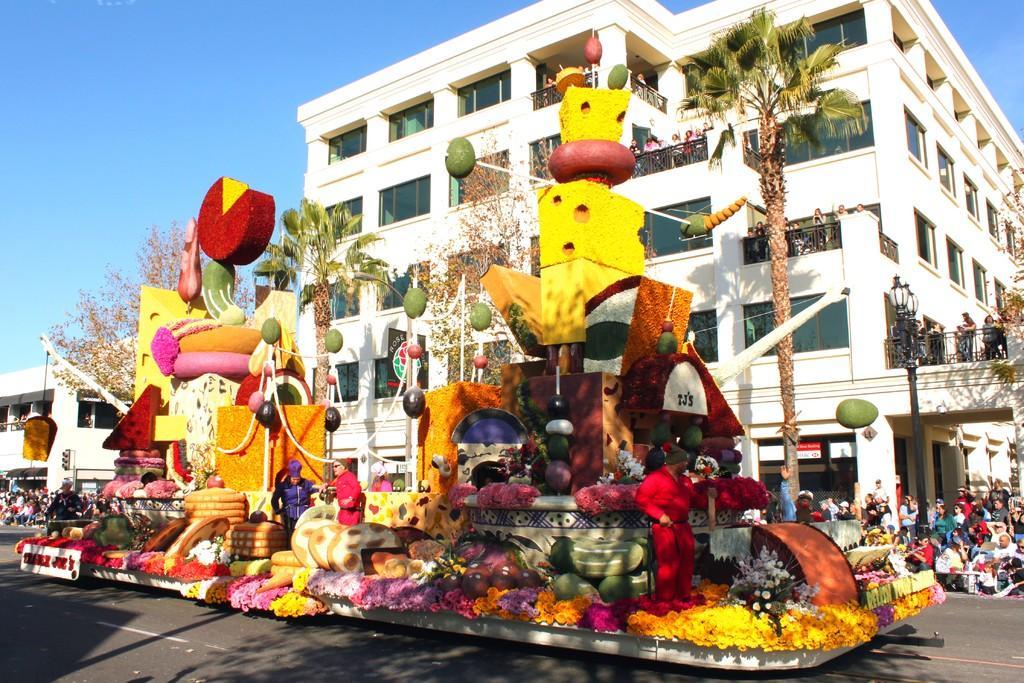Please provide a concise description of this image. In this image in the foreground there are some toys, and some toy fruits and some objects and there are group of people. At the bottom there is road, and in the background there are buildings, trees, poles, lights, and at the top there is sky. 